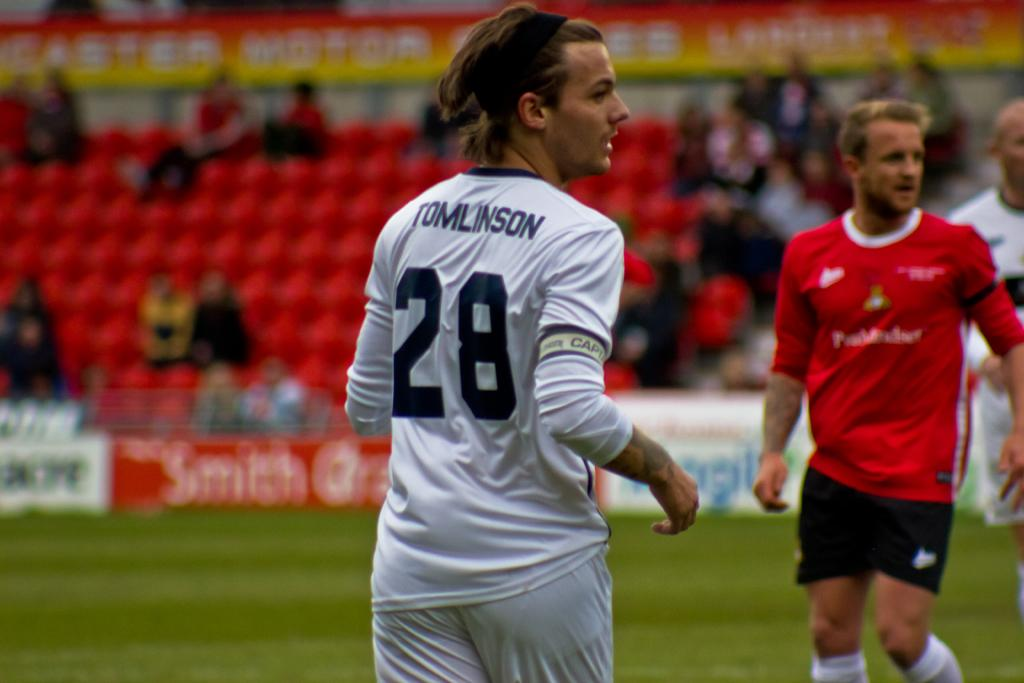What type of people can be seen in the image? There are sportspeople in the image. What can be seen in the background of the image? There are bleachers in the background of the image. What are the bleachers being used for? There are people sitting in the bleachers, suggesting they are being used for spectators. What else is visible in the image? There are boards visible in the image. What type of yarn is being used to create the curtains in the image? There are no curtains present in the image, so it is not possible to determine the type of yarn being used. 